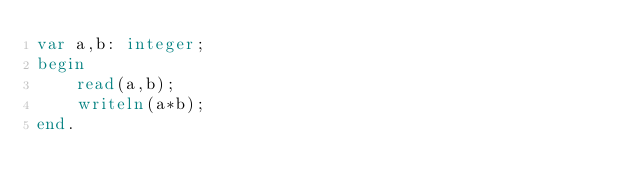Convert code to text. <code><loc_0><loc_0><loc_500><loc_500><_Pascal_>var a,b: integer;
begin
    read(a,b);
    writeln(a*b);
end.
</code> 